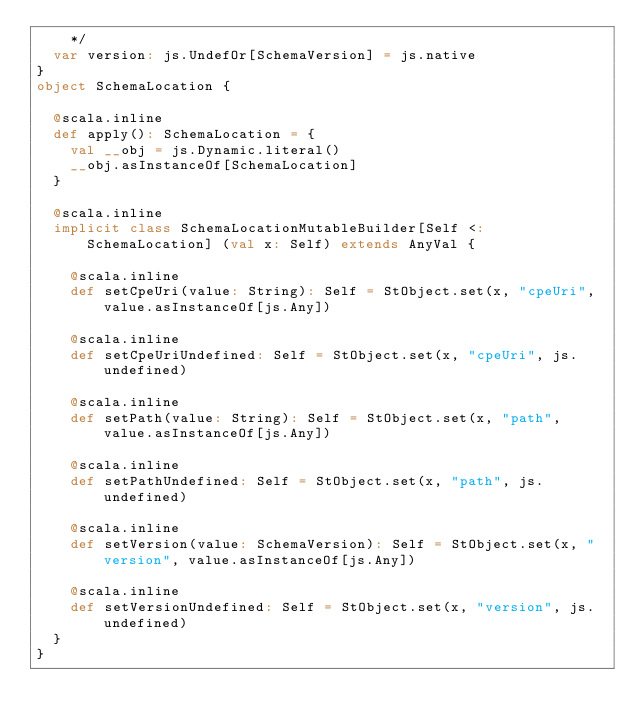<code> <loc_0><loc_0><loc_500><loc_500><_Scala_>    */
  var version: js.UndefOr[SchemaVersion] = js.native
}
object SchemaLocation {
  
  @scala.inline
  def apply(): SchemaLocation = {
    val __obj = js.Dynamic.literal()
    __obj.asInstanceOf[SchemaLocation]
  }
  
  @scala.inline
  implicit class SchemaLocationMutableBuilder[Self <: SchemaLocation] (val x: Self) extends AnyVal {
    
    @scala.inline
    def setCpeUri(value: String): Self = StObject.set(x, "cpeUri", value.asInstanceOf[js.Any])
    
    @scala.inline
    def setCpeUriUndefined: Self = StObject.set(x, "cpeUri", js.undefined)
    
    @scala.inline
    def setPath(value: String): Self = StObject.set(x, "path", value.asInstanceOf[js.Any])
    
    @scala.inline
    def setPathUndefined: Self = StObject.set(x, "path", js.undefined)
    
    @scala.inline
    def setVersion(value: SchemaVersion): Self = StObject.set(x, "version", value.asInstanceOf[js.Any])
    
    @scala.inline
    def setVersionUndefined: Self = StObject.set(x, "version", js.undefined)
  }
}
</code> 